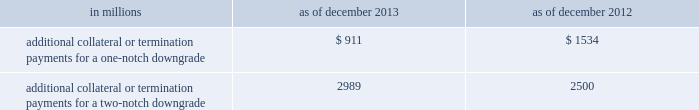Management 2019s discussion and analysis we believe our credit ratings are primarily based on the credit rating agencies 2019 assessment of : 2030 our liquidity , market , credit and operational risk management practices ; 2030 the level and variability of our earnings ; 2030 our capital base ; 2030 our franchise , reputation and management ; 2030 our corporate governance ; and 2030 the external operating environment , including the assumed level of government support .
Certain of the firm 2019s derivatives have been transacted under bilateral agreements with counterparties who may require us to post collateral or terminate the transactions based on changes in our credit ratings .
We assess the impact of these bilateral agreements by determining the collateral or termination payments that would occur assuming a downgrade by all rating agencies .
A downgrade by any one rating agency , depending on the agency 2019s relative ratings of the firm at the time of the downgrade , may have an impact which is comparable to the impact of a downgrade by all rating agencies .
We allocate a portion of our gce to ensure we would be able to make the additional collateral or termination payments that may be required in the event of a two-notch reduction in our long-term credit ratings , as well as collateral that has not been called by counterparties , but is available to them .
The table below presents the additional collateral or termination payments related to our net derivative liabilities under bilateral agreements that could have been called at the reporting date by counterparties in the event of a one-notch and two-notch downgrade in our credit ratings. .
In millions 2013 2012 additional collateral or termination payments for a one-notch downgrade $ 911 $ 1534 additional collateral or termination payments for a two-notch downgrade 2989 2500 cash flows as a global financial institution , our cash flows are complex and bear little relation to our net earnings and net assets .
Consequently , we believe that traditional cash flow analysis is less meaningful in evaluating our liquidity position than the excess liquidity and asset-liability management policies described above .
Cash flow analysis may , however , be helpful in highlighting certain macro trends and strategic initiatives in our businesses .
Year ended december 2013 .
Our cash and cash equivalents decreased by $ 11.54 billion to $ 61.13 billion at the end of 2013 .
We generated $ 4.54 billion in net cash from operating activities .
We used net cash of $ 16.08 billion for investing and financing activities , primarily to fund loans held for investment and repurchases of common stock .
Year ended december 2012 .
Our cash and cash equivalents increased by $ 16.66 billion to $ 72.67 billion at the end of 2012 .
We generated $ 9.14 billion in net cash from operating and investing activities .
We generated $ 7.52 billion in net cash from financing activities from an increase in bank deposits , partially offset by net repayments of unsecured and secured long-term borrowings .
Year ended december 2011 .
Our cash and cash equivalents increased by $ 16.22 billion to $ 56.01 billion at the end of 2011 .
We generated $ 23.13 billion in net cash from operating and investing activities .
We used net cash of $ 6.91 billion for financing activities , primarily for repurchases of our series g preferred stock and common stock , partially offset by an increase in bank deposits .
Goldman sachs 2013 annual report 89 .
What is the difference in millions , between additional collateral or termination payments for a two-notch downgrade and additional collateral or termination payments for a one-notch downgrade at the end of december 2013? 
Computations: (2989 - 911)
Answer: 2078.0. Management 2019s discussion and analysis we believe our credit ratings are primarily based on the credit rating agencies 2019 assessment of : 2030 our liquidity , market , credit and operational risk management practices ; 2030 the level and variability of our earnings ; 2030 our capital base ; 2030 our franchise , reputation and management ; 2030 our corporate governance ; and 2030 the external operating environment , including the assumed level of government support .
Certain of the firm 2019s derivatives have been transacted under bilateral agreements with counterparties who may require us to post collateral or terminate the transactions based on changes in our credit ratings .
We assess the impact of these bilateral agreements by determining the collateral or termination payments that would occur assuming a downgrade by all rating agencies .
A downgrade by any one rating agency , depending on the agency 2019s relative ratings of the firm at the time of the downgrade , may have an impact which is comparable to the impact of a downgrade by all rating agencies .
We allocate a portion of our gce to ensure we would be able to make the additional collateral or termination payments that may be required in the event of a two-notch reduction in our long-term credit ratings , as well as collateral that has not been called by counterparties , but is available to them .
The table below presents the additional collateral or termination payments related to our net derivative liabilities under bilateral agreements that could have been called at the reporting date by counterparties in the event of a one-notch and two-notch downgrade in our credit ratings. .
In millions 2013 2012 additional collateral or termination payments for a one-notch downgrade $ 911 $ 1534 additional collateral or termination payments for a two-notch downgrade 2989 2500 cash flows as a global financial institution , our cash flows are complex and bear little relation to our net earnings and net assets .
Consequently , we believe that traditional cash flow analysis is less meaningful in evaluating our liquidity position than the excess liquidity and asset-liability management policies described above .
Cash flow analysis may , however , be helpful in highlighting certain macro trends and strategic initiatives in our businesses .
Year ended december 2013 .
Our cash and cash equivalents decreased by $ 11.54 billion to $ 61.13 billion at the end of 2013 .
We generated $ 4.54 billion in net cash from operating activities .
We used net cash of $ 16.08 billion for investing and financing activities , primarily to fund loans held for investment and repurchases of common stock .
Year ended december 2012 .
Our cash and cash equivalents increased by $ 16.66 billion to $ 72.67 billion at the end of 2012 .
We generated $ 9.14 billion in net cash from operating and investing activities .
We generated $ 7.52 billion in net cash from financing activities from an increase in bank deposits , partially offset by net repayments of unsecured and secured long-term borrowings .
Year ended december 2011 .
Our cash and cash equivalents increased by $ 16.22 billion to $ 56.01 billion at the end of 2011 .
We generated $ 23.13 billion in net cash from operating and investing activities .
We used net cash of $ 6.91 billion for financing activities , primarily for repurchases of our series g preferred stock and common stock , partially offset by an increase in bank deposits .
Goldman sachs 2013 annual report 89 .
What is the difference in millions , between additional collateral or termination payments for a two-notch downgrade and additional collateral or termination payments for a one-notch downgrade at the end of december 2012? 
Computations: (2500 - 1534)
Answer: 966.0. 